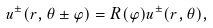Convert formula to latex. <formula><loc_0><loc_0><loc_500><loc_500>u ^ { \pm } ( r , \theta \pm \varphi ) = R ( \varphi ) u ^ { \pm } ( r , \theta ) ,</formula> 